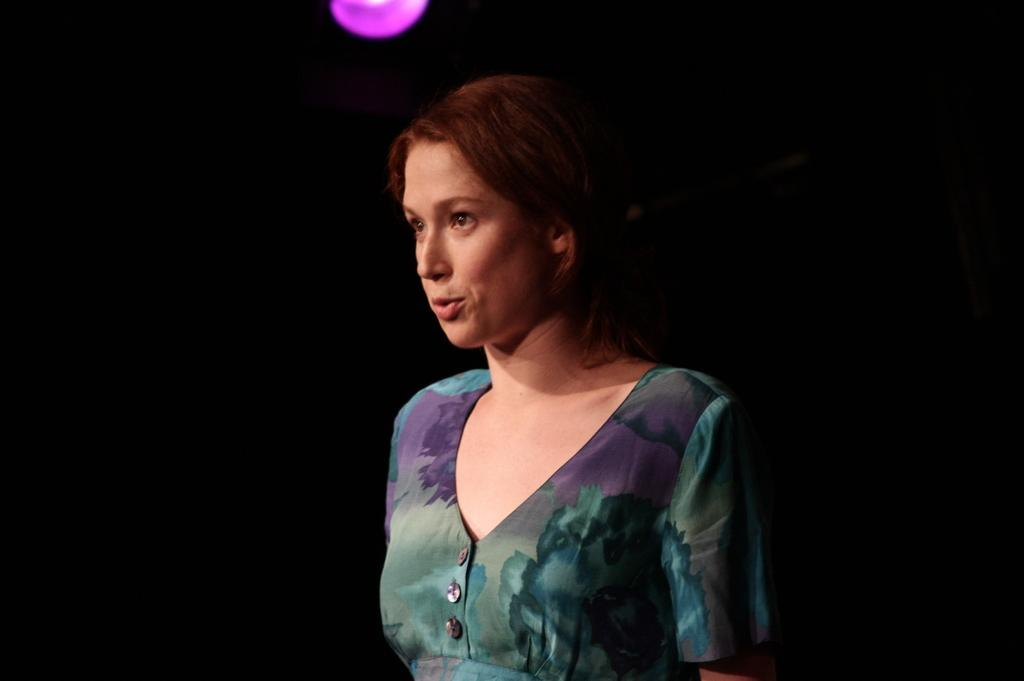Who is the main subject in the image? There is a woman in the image. What is the woman wearing? The woman is wearing a floral dress. What is the color of the background in the image? The background in the image is black. What can be seen at the top of the image? There is light visible at the top of the image. How many flowers are in the woman's hair in the image? There is no indication that the woman has flowers in her hair in the image. Can you tell me if the woman's daughter is present in the image? There is no mention of a daughter or any other person besides the woman in the image. 